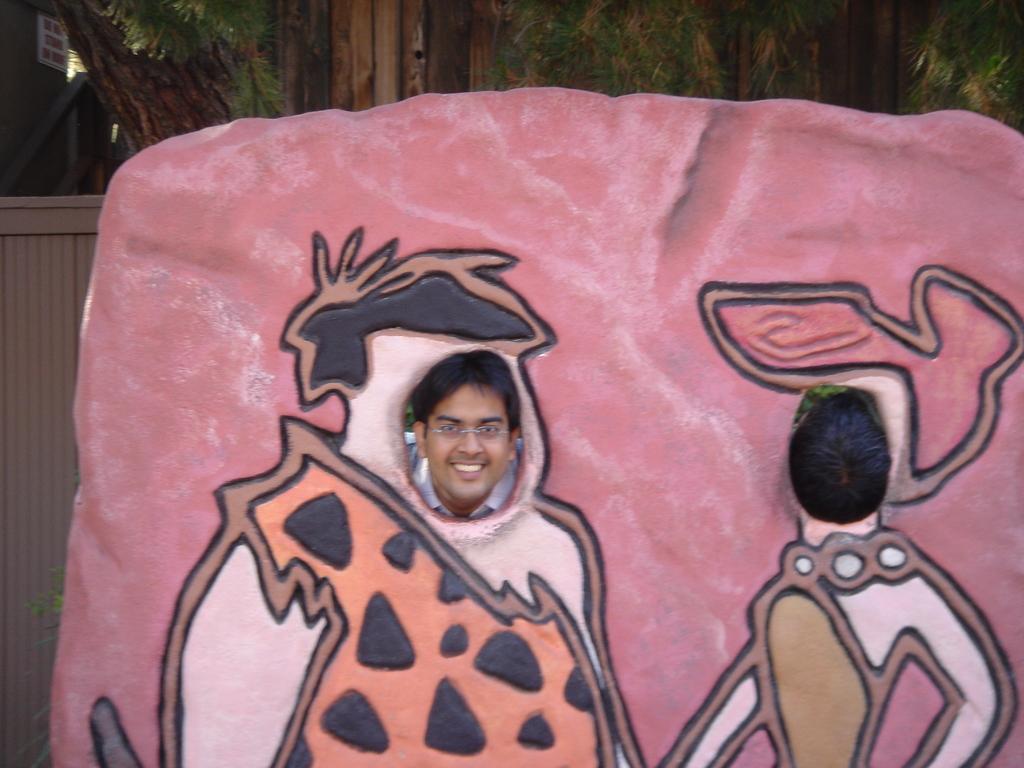How would you summarize this image in a sentence or two? In the center of the image we can see persons head and face through the wall. In the background we can see trees and door. 